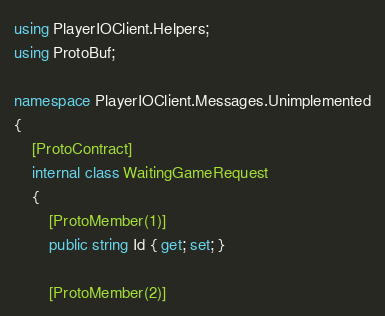<code> <loc_0><loc_0><loc_500><loc_500><_C#_>using PlayerIOClient.Helpers;
using ProtoBuf;

namespace PlayerIOClient.Messages.Unimplemented
{
	[ProtoContract]
	internal class WaitingGameRequest
	{
		[ProtoMember(1)]
		public string Id { get; set; }

		[ProtoMember(2)]</code> 